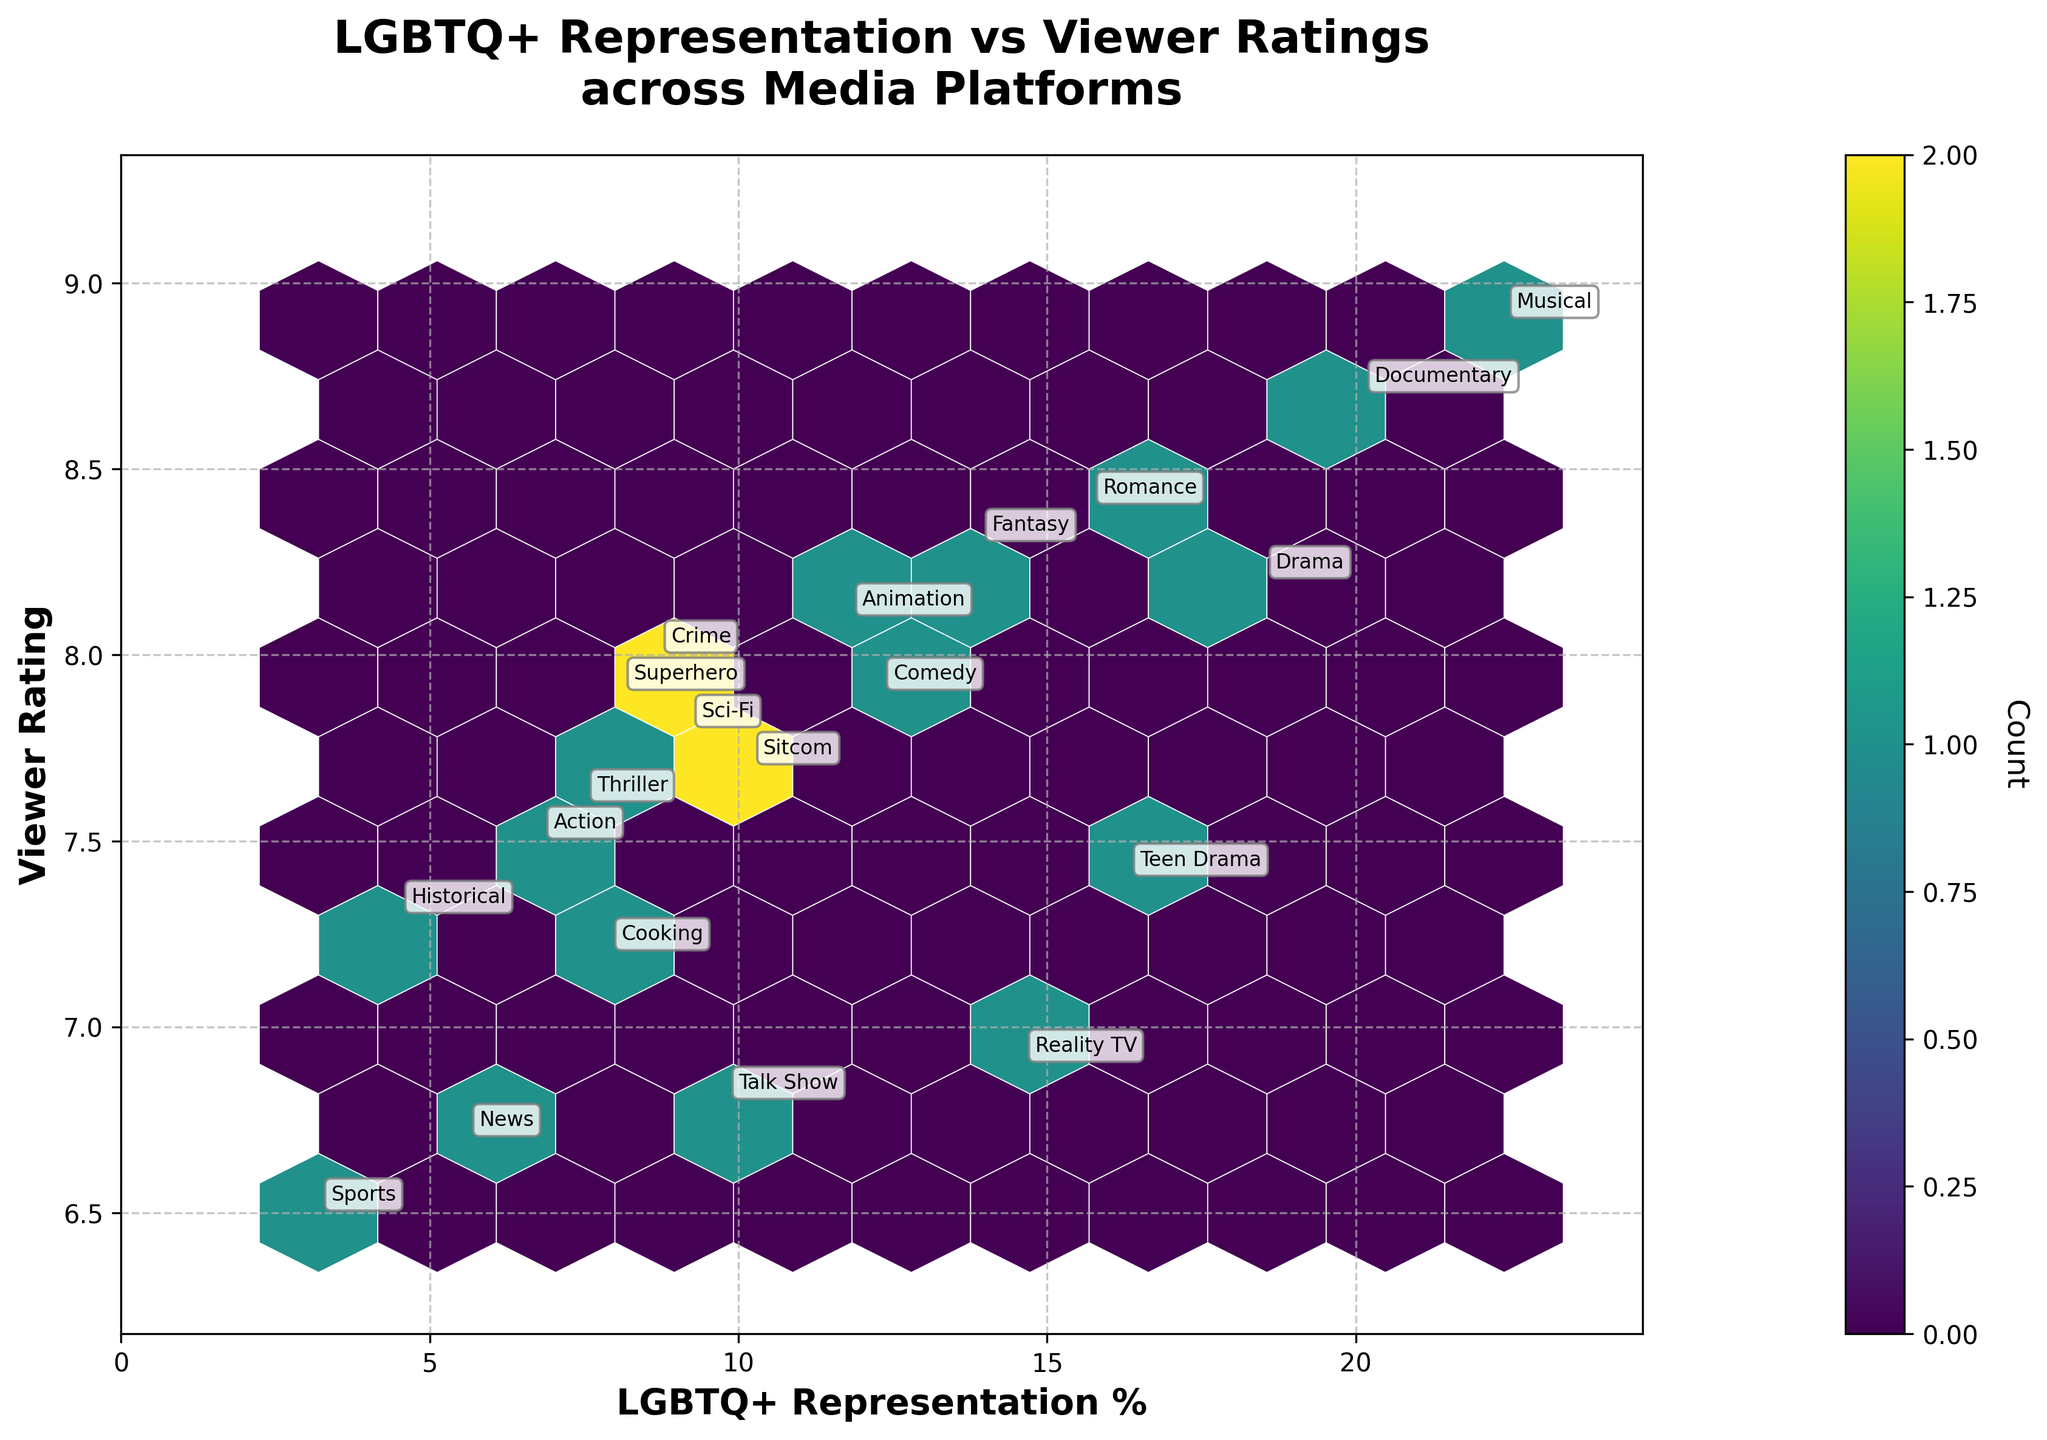What is the title of the plot? The title is usually found at the top of the plot; in this case, it summarizes the main focus.
Answer: LGBTQ+ Representation vs Viewer Ratings across Media Platforms What does the color intensity represent in the plot? The color intensity in hexbin plots typically represents the density of data points within each hexagon. Darker colors indicate higher density.
Answer: Density of data points How many genres show an LGBTQ+ representation of over 15%? Look at the x-axis (LGBTQ+ Representation %) and count the number of labeled genres above the 15% mark.
Answer: 5 Which genre has the highest LGBTQ+ representation? Find the data point farthest to the right on the x-axis, and refer to its annotation.
Answer: Musical What is the average viewer rating for genres with more than 10% LGBTQ+ representation? Identify genres with above 10% representation from the x-axis, then calculate the average of their viewer ratings on the y-axis.
Answer: 8.37 Compare the viewer ratings of the Drama genre on Netflix to the Reality TV genre on Bravo. Which one is higher? Locate both genres on the plot and compare their y-axis values (Viewer Rating).
Answer: Drama What is the relationship between LGBTQ+ representation and viewer ratings shown in the plot? Observe the overall trend of hexagons from left to right and bottom to top to describe any patterns or correlations.
Answer: Slight positive correlation How many genres have a viewer rating below 7? Count the number of labeled data points below the y-axis value of 7.
Answer: 4 Which platform has both a high LGBTQ+ representation and viewer rating? Look for clusters or individual points with high values on both the x-axis and y-axis, then refer to the annotations.
Answer: Broadway HD Is there any genre with high LGBTQ+ representation but a low viewer rating? Identify points far to the right on the x-axis but low on the y-axis and read their annotations.
Answer: No 